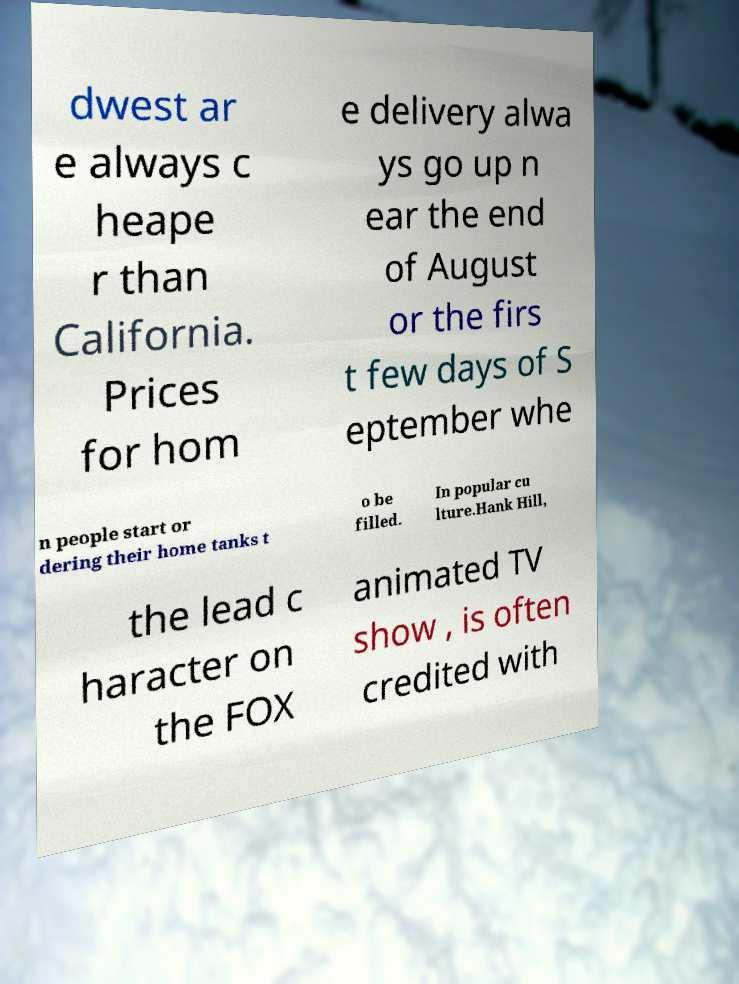Could you extract and type out the text from this image? dwest ar e always c heape r than California. Prices for hom e delivery alwa ys go up n ear the end of August or the firs t few days of S eptember whe n people start or dering their home tanks t o be filled. In popular cu lture.Hank Hill, the lead c haracter on the FOX animated TV show , is often credited with 